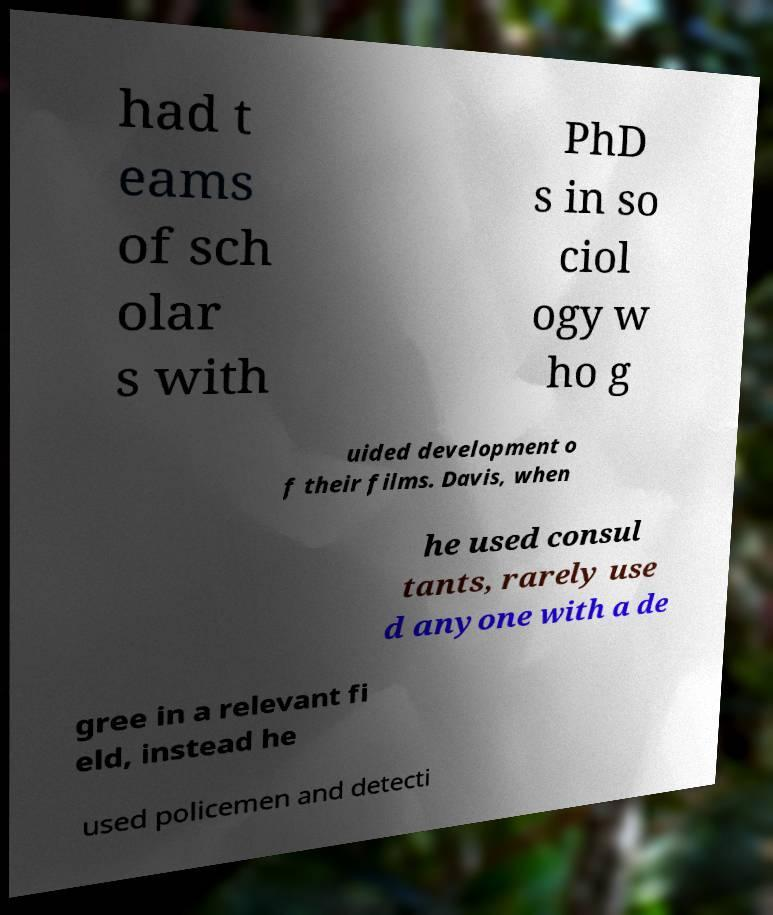Can you read and provide the text displayed in the image?This photo seems to have some interesting text. Can you extract and type it out for me? had t eams of sch olar s with PhD s in so ciol ogy w ho g uided development o f their films. Davis, when he used consul tants, rarely use d anyone with a de gree in a relevant fi eld, instead he used policemen and detecti 